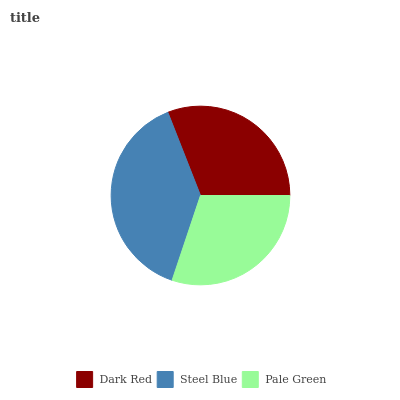Is Pale Green the minimum?
Answer yes or no. Yes. Is Steel Blue the maximum?
Answer yes or no. Yes. Is Steel Blue the minimum?
Answer yes or no. No. Is Pale Green the maximum?
Answer yes or no. No. Is Steel Blue greater than Pale Green?
Answer yes or no. Yes. Is Pale Green less than Steel Blue?
Answer yes or no. Yes. Is Pale Green greater than Steel Blue?
Answer yes or no. No. Is Steel Blue less than Pale Green?
Answer yes or no. No. Is Dark Red the high median?
Answer yes or no. Yes. Is Dark Red the low median?
Answer yes or no. Yes. Is Steel Blue the high median?
Answer yes or no. No. Is Pale Green the low median?
Answer yes or no. No. 